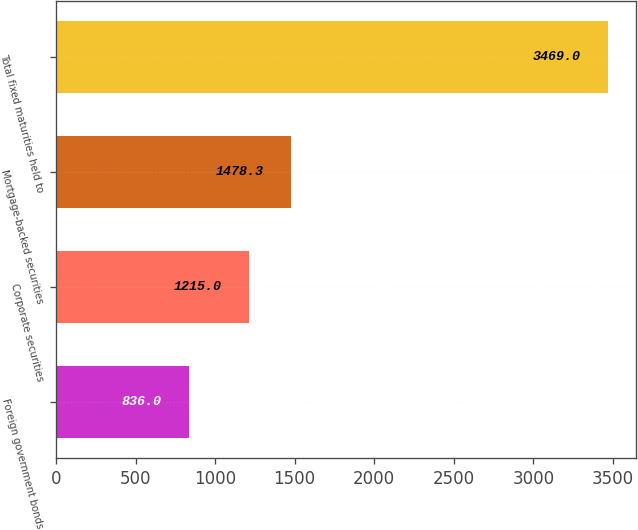Convert chart to OTSL. <chart><loc_0><loc_0><loc_500><loc_500><bar_chart><fcel>Foreign government bonds<fcel>Corporate securities<fcel>Mortgage-backed securities<fcel>Total fixed maturities held to<nl><fcel>836<fcel>1215<fcel>1478.3<fcel>3469<nl></chart> 